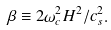Convert formula to latex. <formula><loc_0><loc_0><loc_500><loc_500>\beta \equiv 2 \omega _ { c } ^ { 2 } H ^ { 2 } / c _ { s } ^ { 2 } .</formula> 